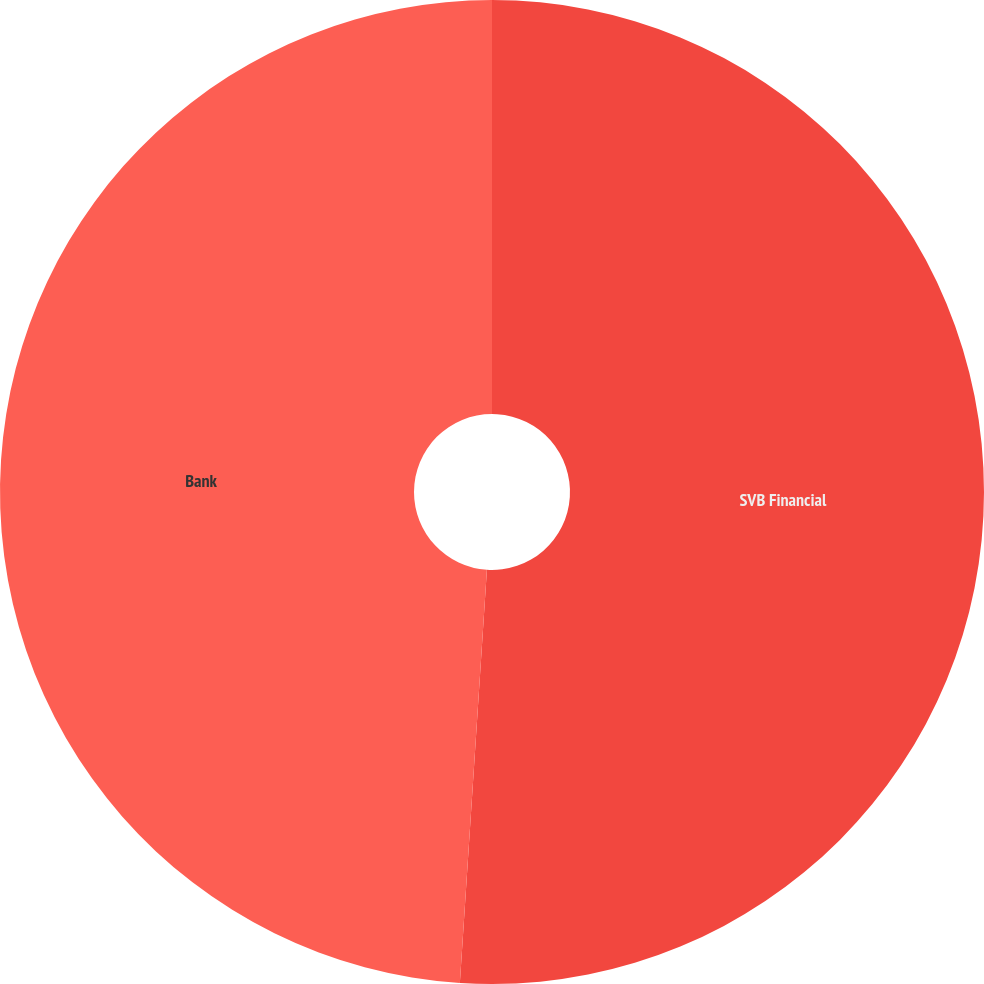Convert chart. <chart><loc_0><loc_0><loc_500><loc_500><pie_chart><fcel>SVB Financial<fcel>Bank<nl><fcel>51.04%<fcel>48.96%<nl></chart> 